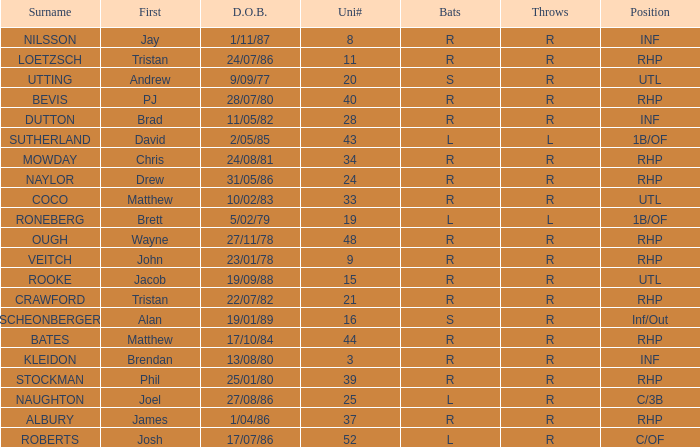Which Uni # has a Surname of ough? 48.0. 